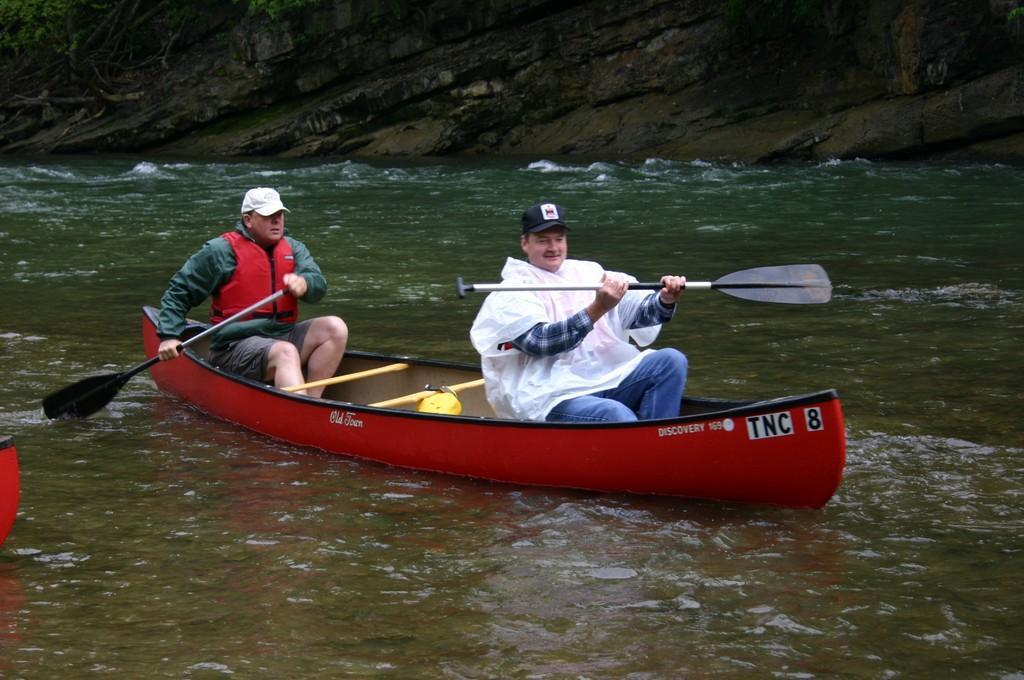Could you give a brief overview of what you see in this image? In this image we can see two persons are sitting on a boat on the water and they are holding paddles in their hands. On the left side we can see an object on the water. In the background we can see cliff and plants. 